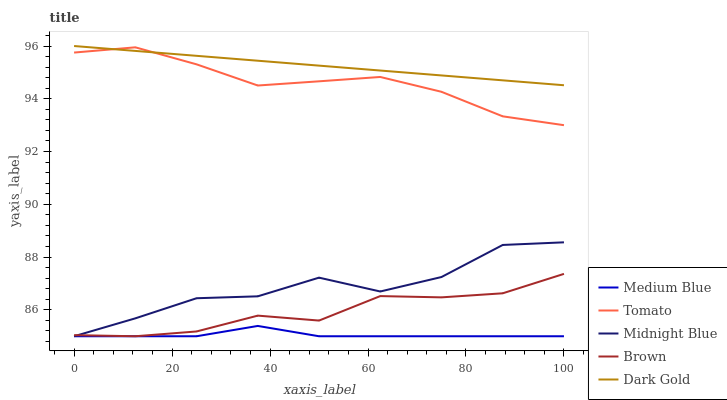Does Medium Blue have the minimum area under the curve?
Answer yes or no. Yes. Does Dark Gold have the maximum area under the curve?
Answer yes or no. Yes. Does Brown have the minimum area under the curve?
Answer yes or no. No. Does Brown have the maximum area under the curve?
Answer yes or no. No. Is Dark Gold the smoothest?
Answer yes or no. Yes. Is Midnight Blue the roughest?
Answer yes or no. Yes. Is Brown the smoothest?
Answer yes or no. No. Is Brown the roughest?
Answer yes or no. No. Does Brown have the lowest value?
Answer yes or no. Yes. Does Dark Gold have the lowest value?
Answer yes or no. No. Does Dark Gold have the highest value?
Answer yes or no. Yes. Does Brown have the highest value?
Answer yes or no. No. Is Midnight Blue less than Dark Gold?
Answer yes or no. Yes. Is Dark Gold greater than Brown?
Answer yes or no. Yes. Does Medium Blue intersect Brown?
Answer yes or no. Yes. Is Medium Blue less than Brown?
Answer yes or no. No. Is Medium Blue greater than Brown?
Answer yes or no. No. Does Midnight Blue intersect Dark Gold?
Answer yes or no. No. 